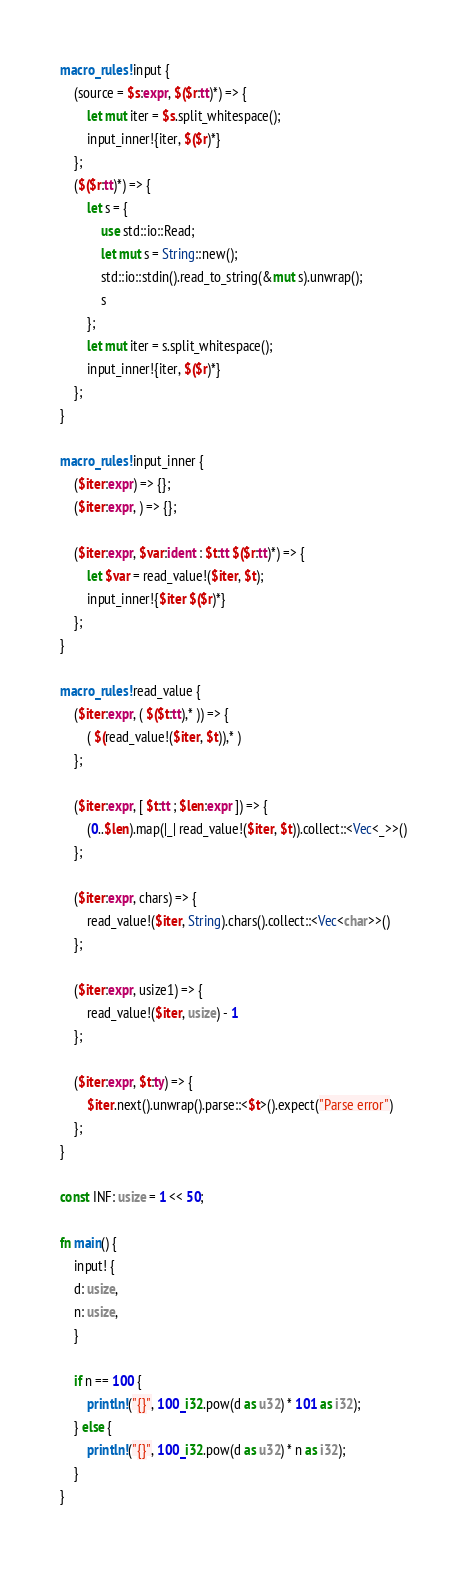<code> <loc_0><loc_0><loc_500><loc_500><_Rust_>macro_rules! input {
    (source = $s:expr, $($r:tt)*) => {
        let mut iter = $s.split_whitespace();
        input_inner!{iter, $($r)*}
    };
    ($($r:tt)*) => {
        let s = {
            use std::io::Read;
            let mut s = String::new();
            std::io::stdin().read_to_string(&mut s).unwrap();
            s
        };
        let mut iter = s.split_whitespace();
        input_inner!{iter, $($r)*}
    };
}

macro_rules! input_inner {
    ($iter:expr) => {};
    ($iter:expr, ) => {};

    ($iter:expr, $var:ident : $t:tt $($r:tt)*) => {
        let $var = read_value!($iter, $t);
        input_inner!{$iter $($r)*}
    };
}

macro_rules! read_value {
    ($iter:expr, ( $($t:tt),* )) => {
        ( $(read_value!($iter, $t)),* )
    };

    ($iter:expr, [ $t:tt ; $len:expr ]) => {
        (0..$len).map(|_| read_value!($iter, $t)).collect::<Vec<_>>()
    };

    ($iter:expr, chars) => {
        read_value!($iter, String).chars().collect::<Vec<char>>()
    };

    ($iter:expr, usize1) => {
        read_value!($iter, usize) - 1
    };

    ($iter:expr, $t:ty) => {
        $iter.next().unwrap().parse::<$t>().expect("Parse error")
    };
}

const INF: usize = 1 << 50;

fn main() {
    input! {
    d: usize,
    n: usize,
    }

    if n == 100 {
        println!("{}", 100_i32.pow(d as u32) * 101 as i32);
    } else {
        println!("{}", 100_i32.pow(d as u32) * n as i32);
    }
}
</code> 